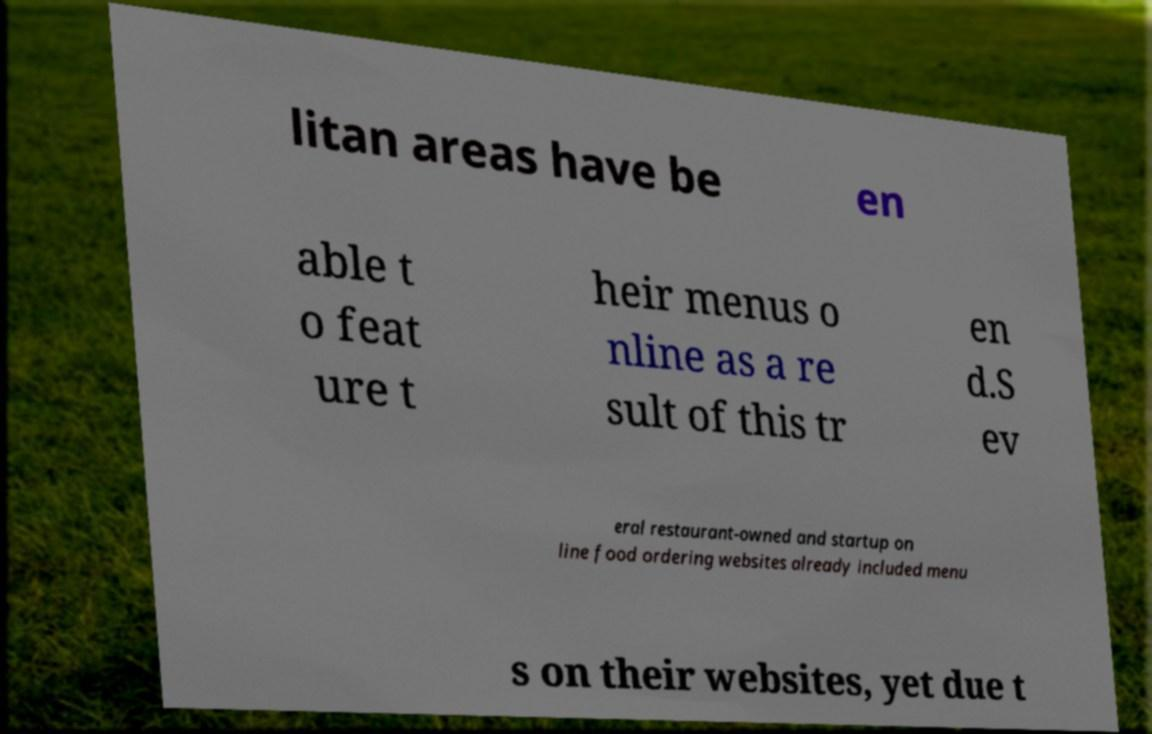I need the written content from this picture converted into text. Can you do that? litan areas have be en able t o feat ure t heir menus o nline as a re sult of this tr en d.S ev eral restaurant-owned and startup on line food ordering websites already included menu s on their websites, yet due t 